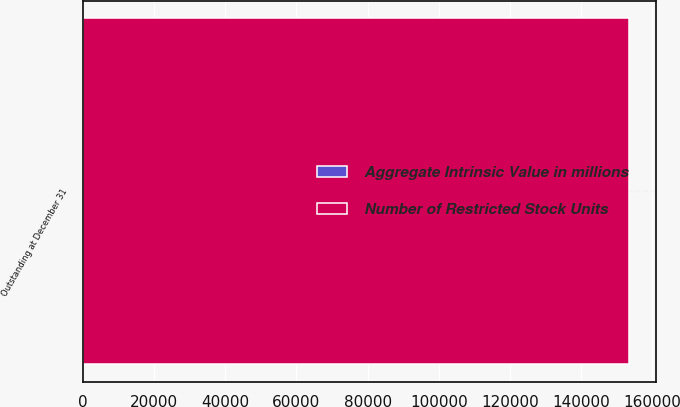<chart> <loc_0><loc_0><loc_500><loc_500><stacked_bar_chart><ecel><fcel>Outstanding at December 31<nl><fcel>Number of Restricted Stock Units<fcel>153278<nl><fcel>Aggregate Intrinsic Value in millions<fcel>23.2<nl></chart> 